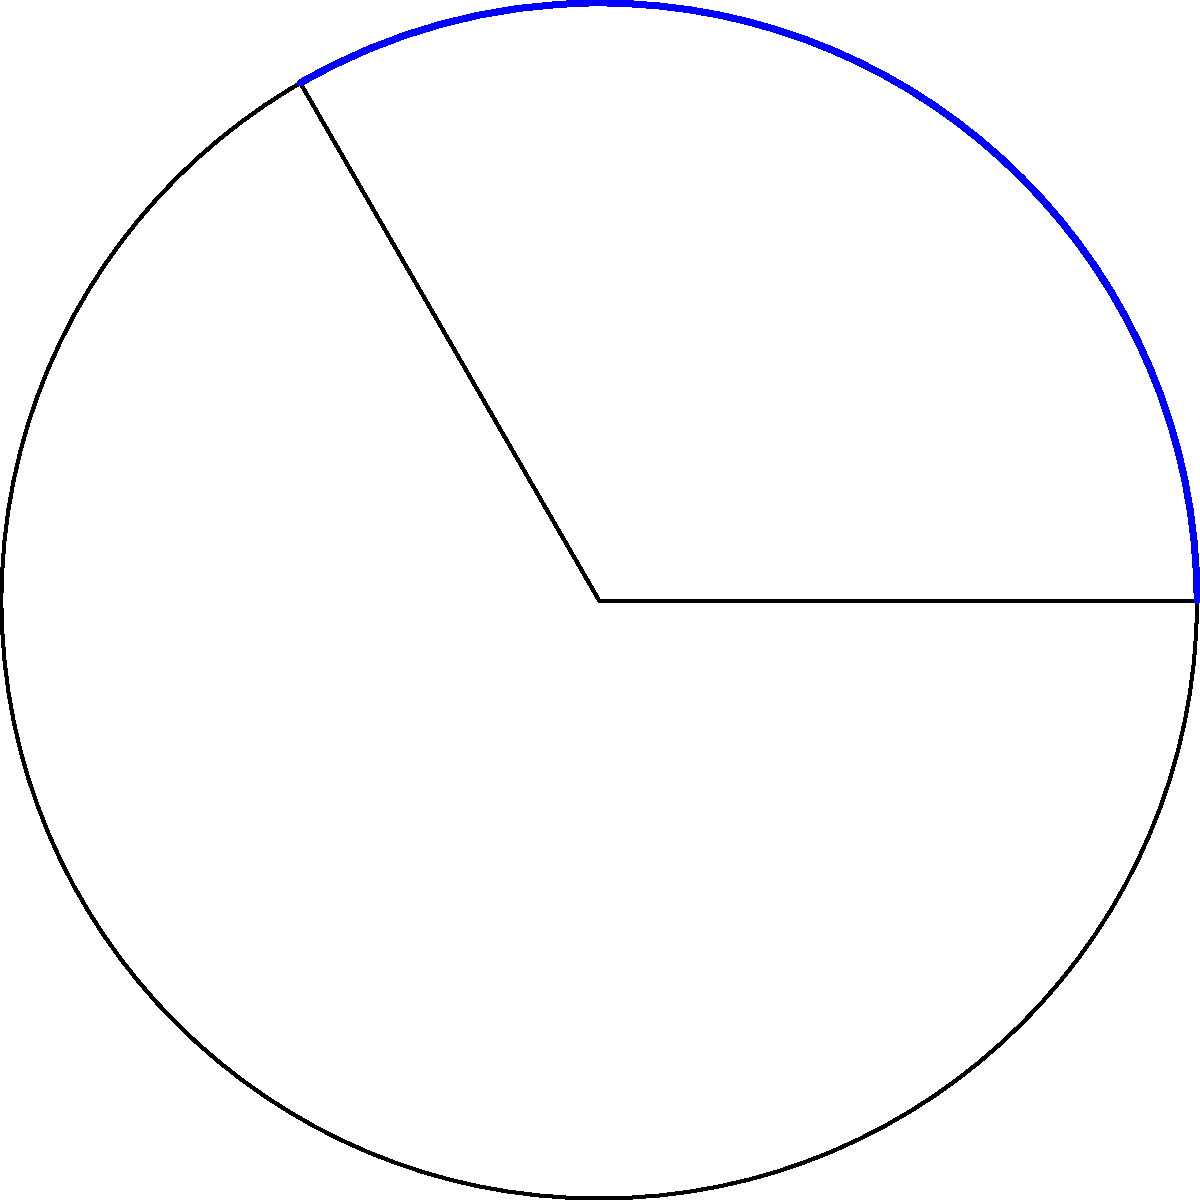In a circular sector with radius $r = 10$ cm and central angle $\theta = 120°$, what is the ratio of the sector's area to the area of the entire circle? Express your answer as a fraction in its simplest form. Let's approach this step-by-step:

1) First, recall the formula for the area of a circular sector:
   $$A_{sector} = \frac{\theta}{360°} \pi r^2$$
   where $\theta$ is in degrees.

2) The area of the entire circle is given by:
   $$A_{circle} = \pi r^2$$

3) The ratio we're looking for is:
   $$\frac{A_{sector}}{A_{circle}} = \frac{\frac{\theta}{360°} \pi r^2}{\pi r^2}$$

4) Notice that $\pi r^2$ cancels out in the numerator and denominator:
   $$\frac{A_{sector}}{A_{circle}} = \frac{\theta}{360°}$$

5) Now, we can substitute the given value for $\theta$:
   $$\frac{A_{sector}}{A_{circle}} = \frac{120°}{360°}$$

6) Simplify this fraction:
   $$\frac{A_{sector}}{A_{circle}} = \frac{1}{3}$$

Thus, the area of the sector is one-third of the area of the entire circle.
Answer: $\frac{1}{3}$ 